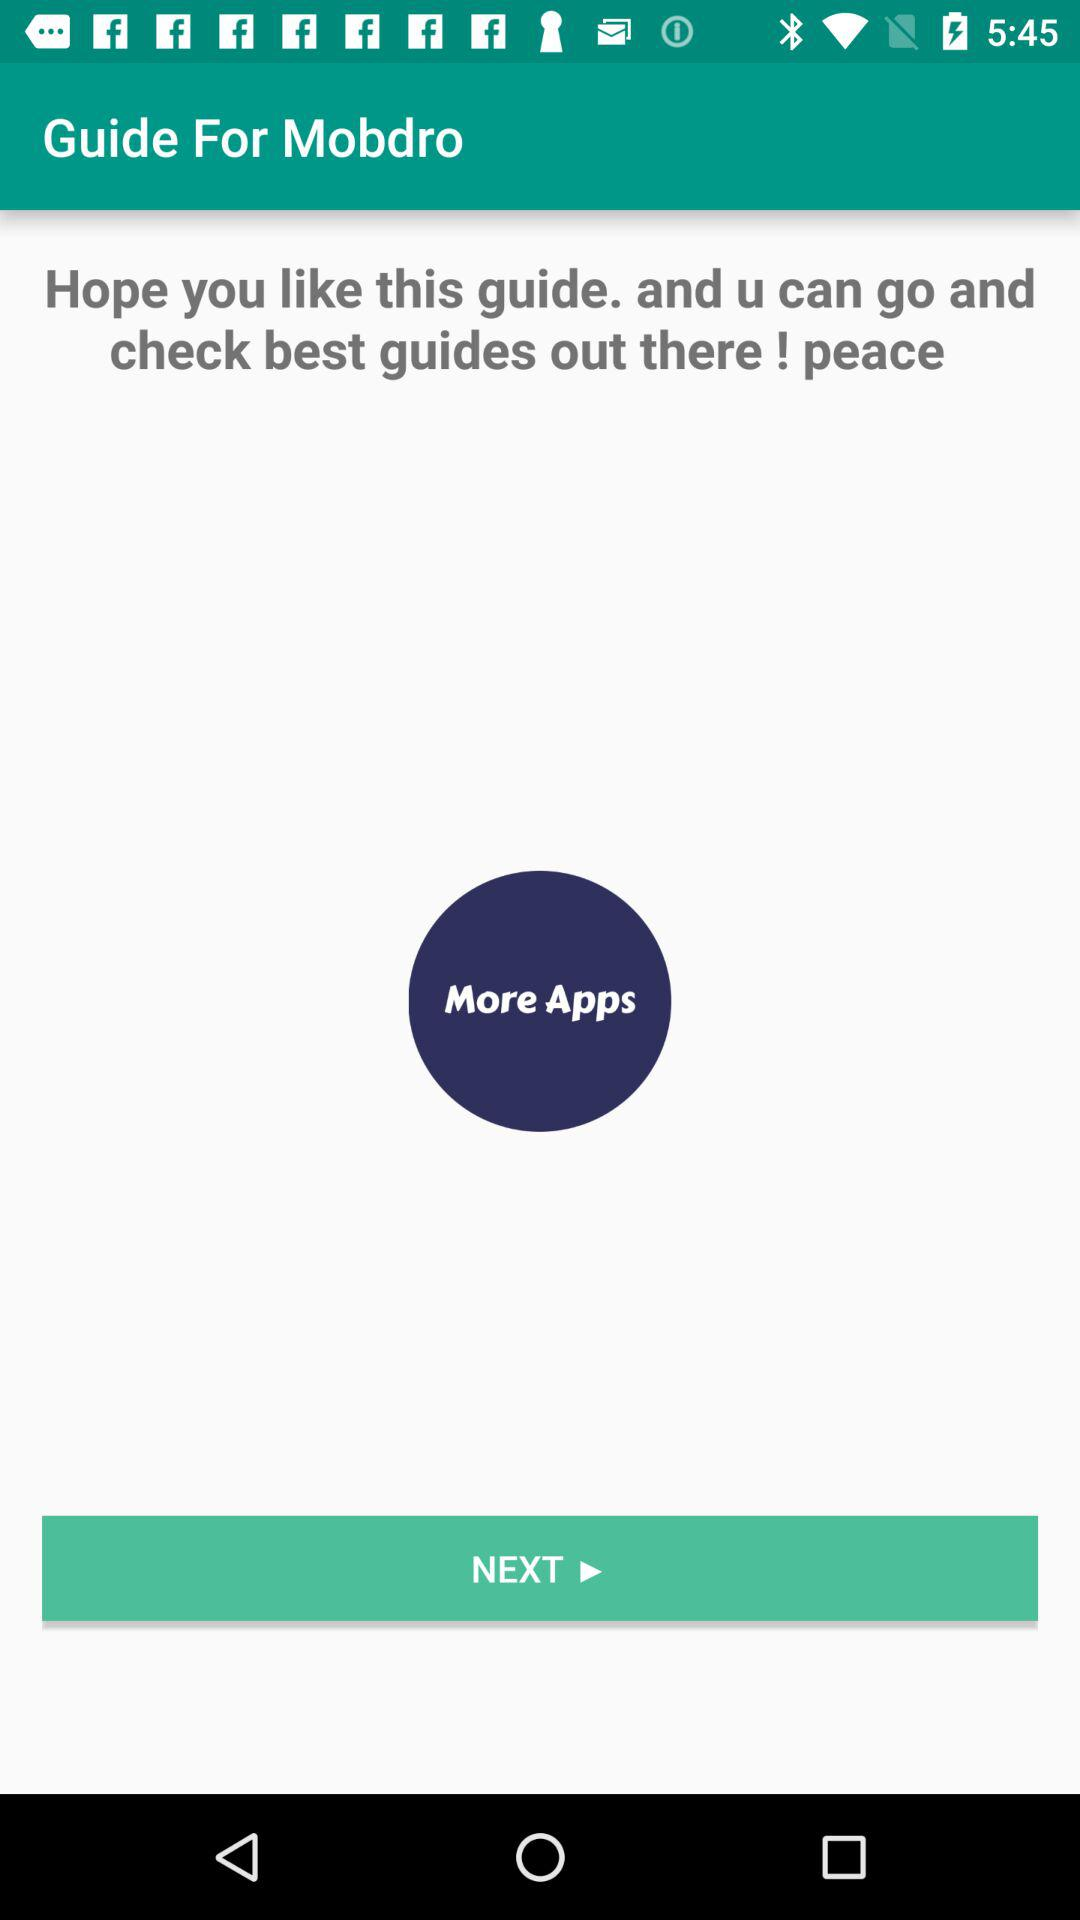What is the name of the application? The name of the application is "Guide For Mobdro". 